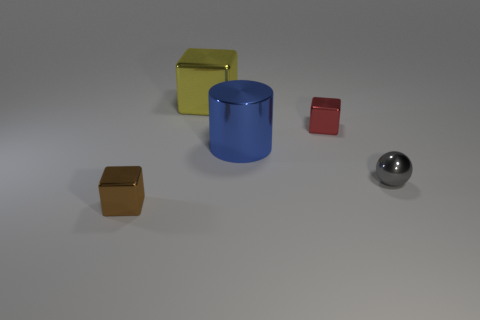Add 4 tiny green objects. How many objects exist? 9 Subtract all spheres. How many objects are left? 4 Add 3 small purple metal objects. How many small purple metal objects exist? 3 Subtract 0 green cubes. How many objects are left? 5 Subtract all cylinders. Subtract all metal cubes. How many objects are left? 1 Add 1 large yellow cubes. How many large yellow cubes are left? 2 